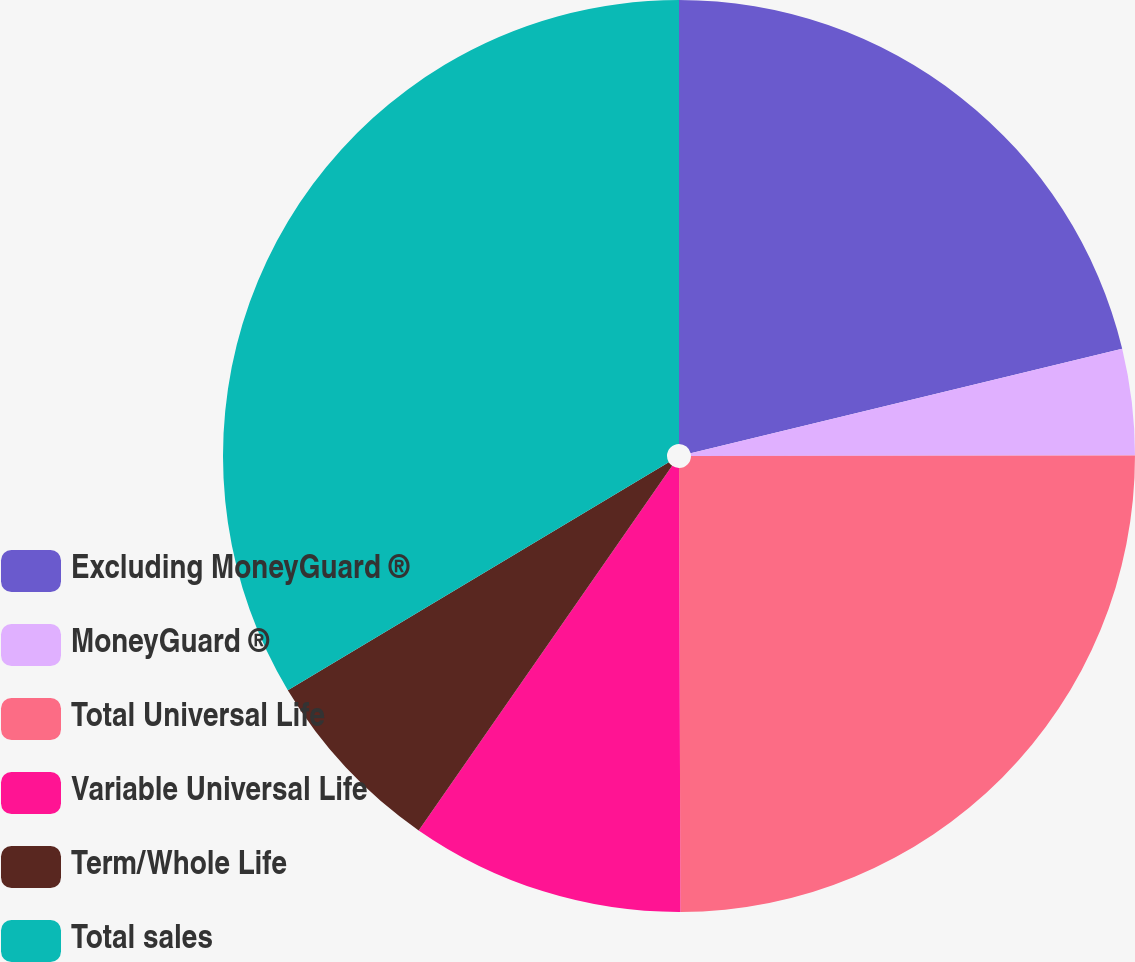Convert chart. <chart><loc_0><loc_0><loc_500><loc_500><pie_chart><fcel>Excluding MoneyGuard ®<fcel>MoneyGuard ®<fcel>Total Universal Life<fcel>Variable Universal Life<fcel>Term/Whole Life<fcel>Total sales<nl><fcel>21.22%<fcel>3.76%<fcel>24.97%<fcel>9.72%<fcel>6.74%<fcel>33.59%<nl></chart> 